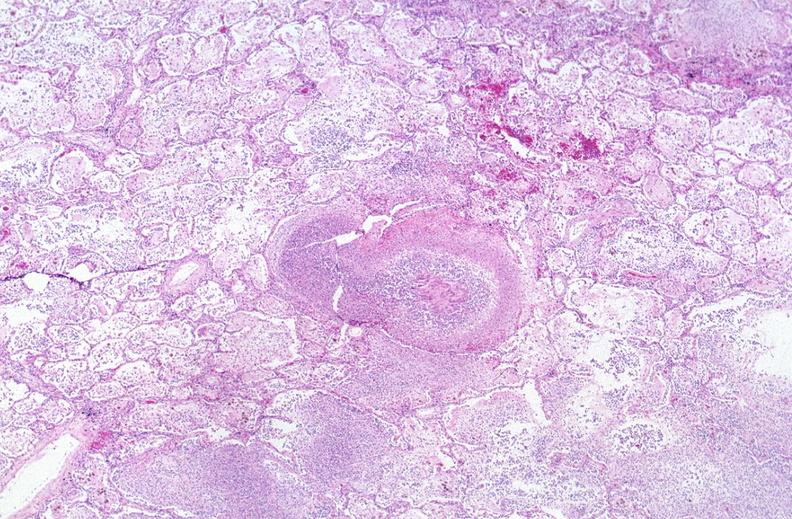s this photo present?
Answer the question using a single word or phrase. No 